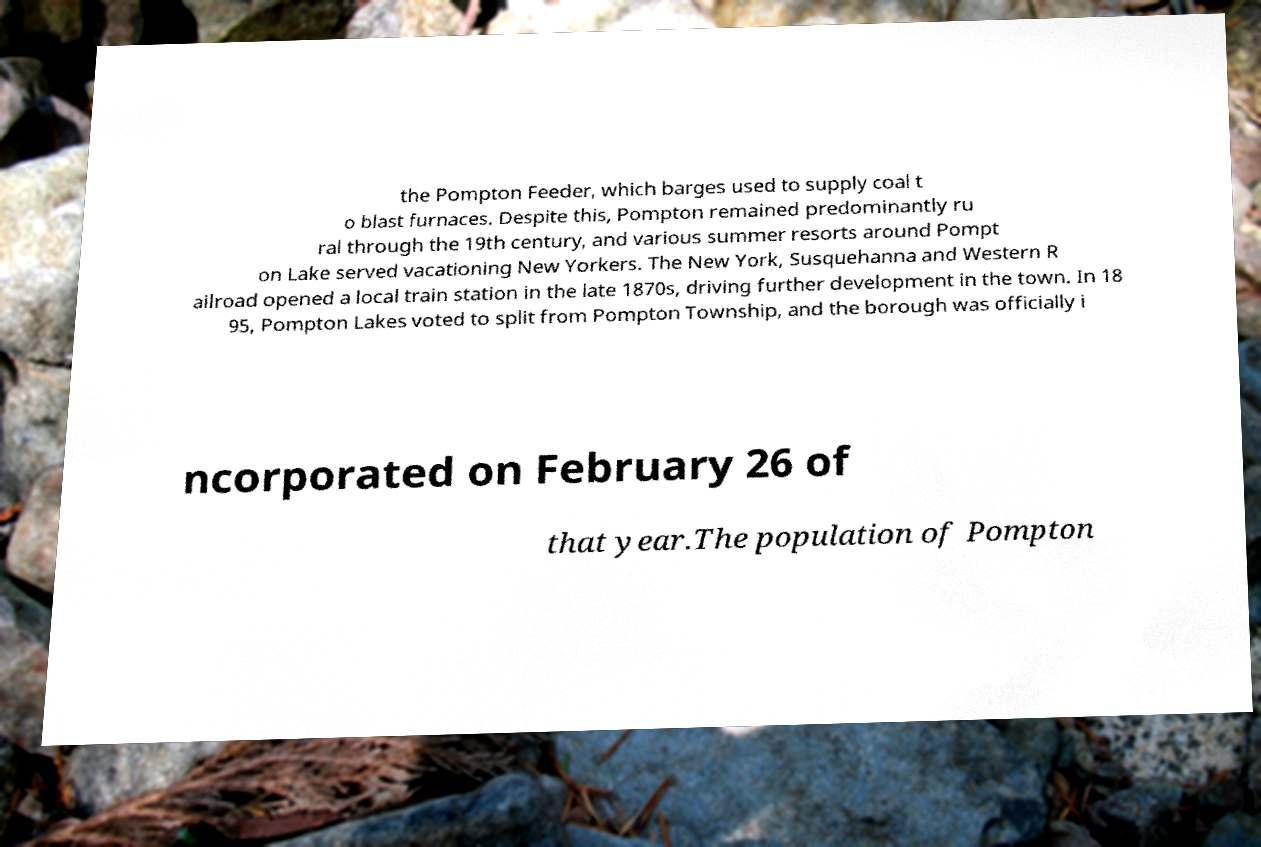Could you assist in decoding the text presented in this image and type it out clearly? the Pompton Feeder, which barges used to supply coal t o blast furnaces. Despite this, Pompton remained predominantly ru ral through the 19th century, and various summer resorts around Pompt on Lake served vacationing New Yorkers. The New York, Susquehanna and Western R ailroad opened a local train station in the late 1870s, driving further development in the town. In 18 95, Pompton Lakes voted to split from Pompton Township, and the borough was officially i ncorporated on February 26 of that year.The population of Pompton 